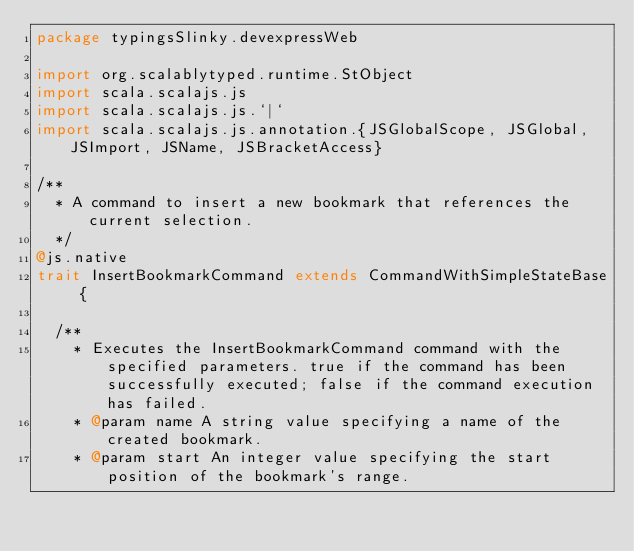Convert code to text. <code><loc_0><loc_0><loc_500><loc_500><_Scala_>package typingsSlinky.devexpressWeb

import org.scalablytyped.runtime.StObject
import scala.scalajs.js
import scala.scalajs.js.`|`
import scala.scalajs.js.annotation.{JSGlobalScope, JSGlobal, JSImport, JSName, JSBracketAccess}

/**
  * A command to insert a new bookmark that references the current selection.
  */
@js.native
trait InsertBookmarkCommand extends CommandWithSimpleStateBase {
  
  /**
    * Executes the InsertBookmarkCommand command with the specified parameters. true if the command has been successfully executed; false if the command execution has failed.
    * @param name A string value specifying a name of the created bookmark.
    * @param start An integer value specifying the start position of the bookmark's range.</code> 